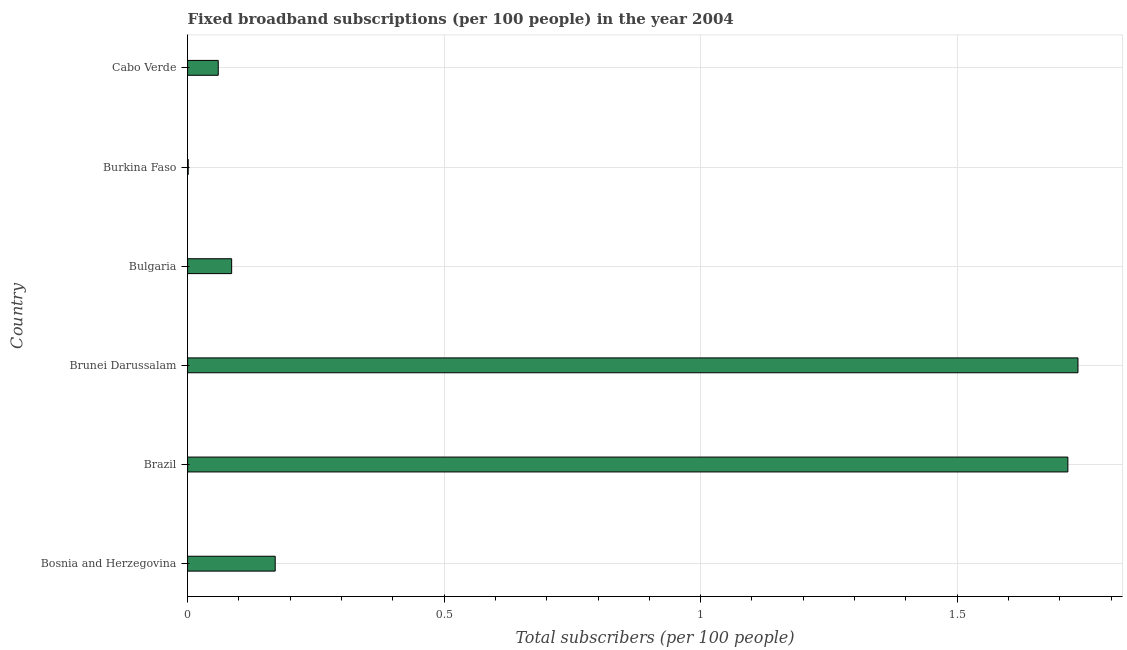Does the graph contain grids?
Offer a terse response. Yes. What is the title of the graph?
Give a very brief answer. Fixed broadband subscriptions (per 100 people) in the year 2004. What is the label or title of the X-axis?
Your response must be concise. Total subscribers (per 100 people). What is the label or title of the Y-axis?
Provide a succinct answer. Country. What is the total number of fixed broadband subscriptions in Burkina Faso?
Keep it short and to the point. 0. Across all countries, what is the maximum total number of fixed broadband subscriptions?
Offer a very short reply. 1.74. Across all countries, what is the minimum total number of fixed broadband subscriptions?
Give a very brief answer. 0. In which country was the total number of fixed broadband subscriptions maximum?
Offer a very short reply. Brunei Darussalam. In which country was the total number of fixed broadband subscriptions minimum?
Your answer should be very brief. Burkina Faso. What is the sum of the total number of fixed broadband subscriptions?
Provide a succinct answer. 3.77. What is the difference between the total number of fixed broadband subscriptions in Brazil and Brunei Darussalam?
Give a very brief answer. -0.02. What is the average total number of fixed broadband subscriptions per country?
Make the answer very short. 0.63. What is the median total number of fixed broadband subscriptions?
Provide a succinct answer. 0.13. What is the ratio of the total number of fixed broadband subscriptions in Bosnia and Herzegovina to that in Burkina Faso?
Your response must be concise. 144.53. Is the total number of fixed broadband subscriptions in Bosnia and Herzegovina less than that in Brazil?
Your answer should be very brief. Yes. What is the difference between the highest and the second highest total number of fixed broadband subscriptions?
Ensure brevity in your answer.  0.02. What is the difference between the highest and the lowest total number of fixed broadband subscriptions?
Offer a terse response. 1.73. How many bars are there?
Your answer should be very brief. 6. Are all the bars in the graph horizontal?
Make the answer very short. Yes. What is the Total subscribers (per 100 people) of Bosnia and Herzegovina?
Your response must be concise. 0.17. What is the Total subscribers (per 100 people) in Brazil?
Ensure brevity in your answer.  1.72. What is the Total subscribers (per 100 people) of Brunei Darussalam?
Give a very brief answer. 1.74. What is the Total subscribers (per 100 people) in Bulgaria?
Ensure brevity in your answer.  0.09. What is the Total subscribers (per 100 people) of Burkina Faso?
Ensure brevity in your answer.  0. What is the Total subscribers (per 100 people) in Cabo Verde?
Your answer should be compact. 0.06. What is the difference between the Total subscribers (per 100 people) in Bosnia and Herzegovina and Brazil?
Make the answer very short. -1.55. What is the difference between the Total subscribers (per 100 people) in Bosnia and Herzegovina and Brunei Darussalam?
Give a very brief answer. -1.56. What is the difference between the Total subscribers (per 100 people) in Bosnia and Herzegovina and Bulgaria?
Provide a succinct answer. 0.08. What is the difference between the Total subscribers (per 100 people) in Bosnia and Herzegovina and Burkina Faso?
Keep it short and to the point. 0.17. What is the difference between the Total subscribers (per 100 people) in Bosnia and Herzegovina and Cabo Verde?
Keep it short and to the point. 0.11. What is the difference between the Total subscribers (per 100 people) in Brazil and Brunei Darussalam?
Your response must be concise. -0.02. What is the difference between the Total subscribers (per 100 people) in Brazil and Bulgaria?
Your answer should be very brief. 1.63. What is the difference between the Total subscribers (per 100 people) in Brazil and Burkina Faso?
Give a very brief answer. 1.71. What is the difference between the Total subscribers (per 100 people) in Brazil and Cabo Verde?
Your answer should be very brief. 1.66. What is the difference between the Total subscribers (per 100 people) in Brunei Darussalam and Bulgaria?
Your answer should be very brief. 1.65. What is the difference between the Total subscribers (per 100 people) in Brunei Darussalam and Burkina Faso?
Make the answer very short. 1.73. What is the difference between the Total subscribers (per 100 people) in Brunei Darussalam and Cabo Verde?
Make the answer very short. 1.68. What is the difference between the Total subscribers (per 100 people) in Bulgaria and Burkina Faso?
Keep it short and to the point. 0.08. What is the difference between the Total subscribers (per 100 people) in Bulgaria and Cabo Verde?
Your answer should be compact. 0.03. What is the difference between the Total subscribers (per 100 people) in Burkina Faso and Cabo Verde?
Your response must be concise. -0.06. What is the ratio of the Total subscribers (per 100 people) in Bosnia and Herzegovina to that in Brazil?
Give a very brief answer. 0.1. What is the ratio of the Total subscribers (per 100 people) in Bosnia and Herzegovina to that in Brunei Darussalam?
Provide a succinct answer. 0.1. What is the ratio of the Total subscribers (per 100 people) in Bosnia and Herzegovina to that in Bulgaria?
Offer a terse response. 1.99. What is the ratio of the Total subscribers (per 100 people) in Bosnia and Herzegovina to that in Burkina Faso?
Your answer should be very brief. 144.53. What is the ratio of the Total subscribers (per 100 people) in Bosnia and Herzegovina to that in Cabo Verde?
Your response must be concise. 2.86. What is the ratio of the Total subscribers (per 100 people) in Brazil to that in Brunei Darussalam?
Make the answer very short. 0.99. What is the ratio of the Total subscribers (per 100 people) in Brazil to that in Bulgaria?
Provide a short and direct response. 19.98. What is the ratio of the Total subscribers (per 100 people) in Brazil to that in Burkina Faso?
Provide a short and direct response. 1452.32. What is the ratio of the Total subscribers (per 100 people) in Brazil to that in Cabo Verde?
Give a very brief answer. 28.71. What is the ratio of the Total subscribers (per 100 people) in Brunei Darussalam to that in Bulgaria?
Your answer should be compact. 20.21. What is the ratio of the Total subscribers (per 100 people) in Brunei Darussalam to that in Burkina Faso?
Give a very brief answer. 1468.98. What is the ratio of the Total subscribers (per 100 people) in Brunei Darussalam to that in Cabo Verde?
Provide a succinct answer. 29.04. What is the ratio of the Total subscribers (per 100 people) in Bulgaria to that in Burkina Faso?
Offer a terse response. 72.69. What is the ratio of the Total subscribers (per 100 people) in Bulgaria to that in Cabo Verde?
Your answer should be compact. 1.44. 